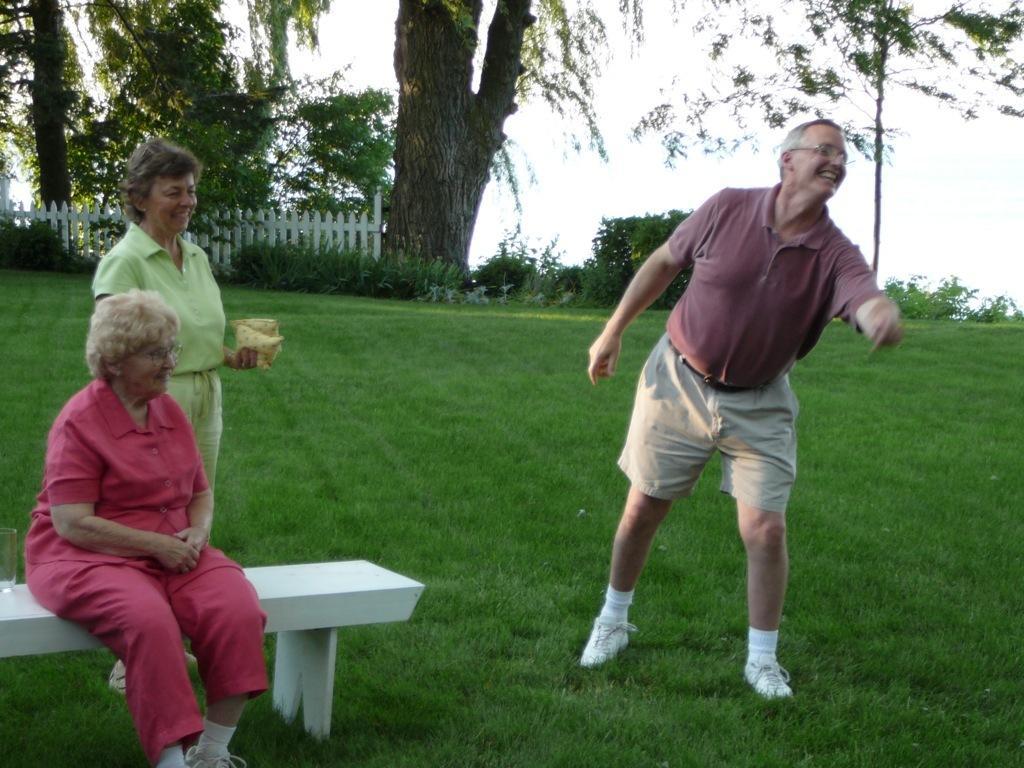Could you give a brief overview of what you see in this image? In this image, there are a few people. Among them, we can see a person sitting on a bench. We can see the ground covered with grass. There are a few plants and trees. We can also see the fence and the sky. 